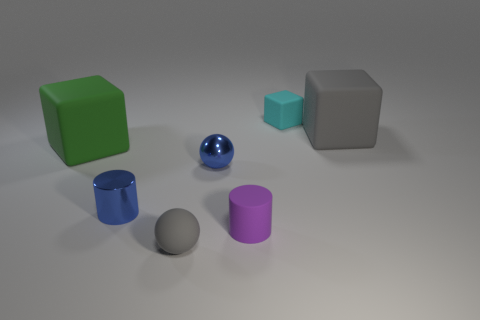Can you describe the lighting in the scene? The lighting in the scene is diffused, creating soft shadows under the objects, indicating a single light source from above.  What could be the possible material of these objects? The objects appear to be made of materials like plastic or metal, as suggested by their smooth surfaces and the way they reflect light. 